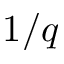Convert formula to latex. <formula><loc_0><loc_0><loc_500><loc_500>1 / q</formula> 